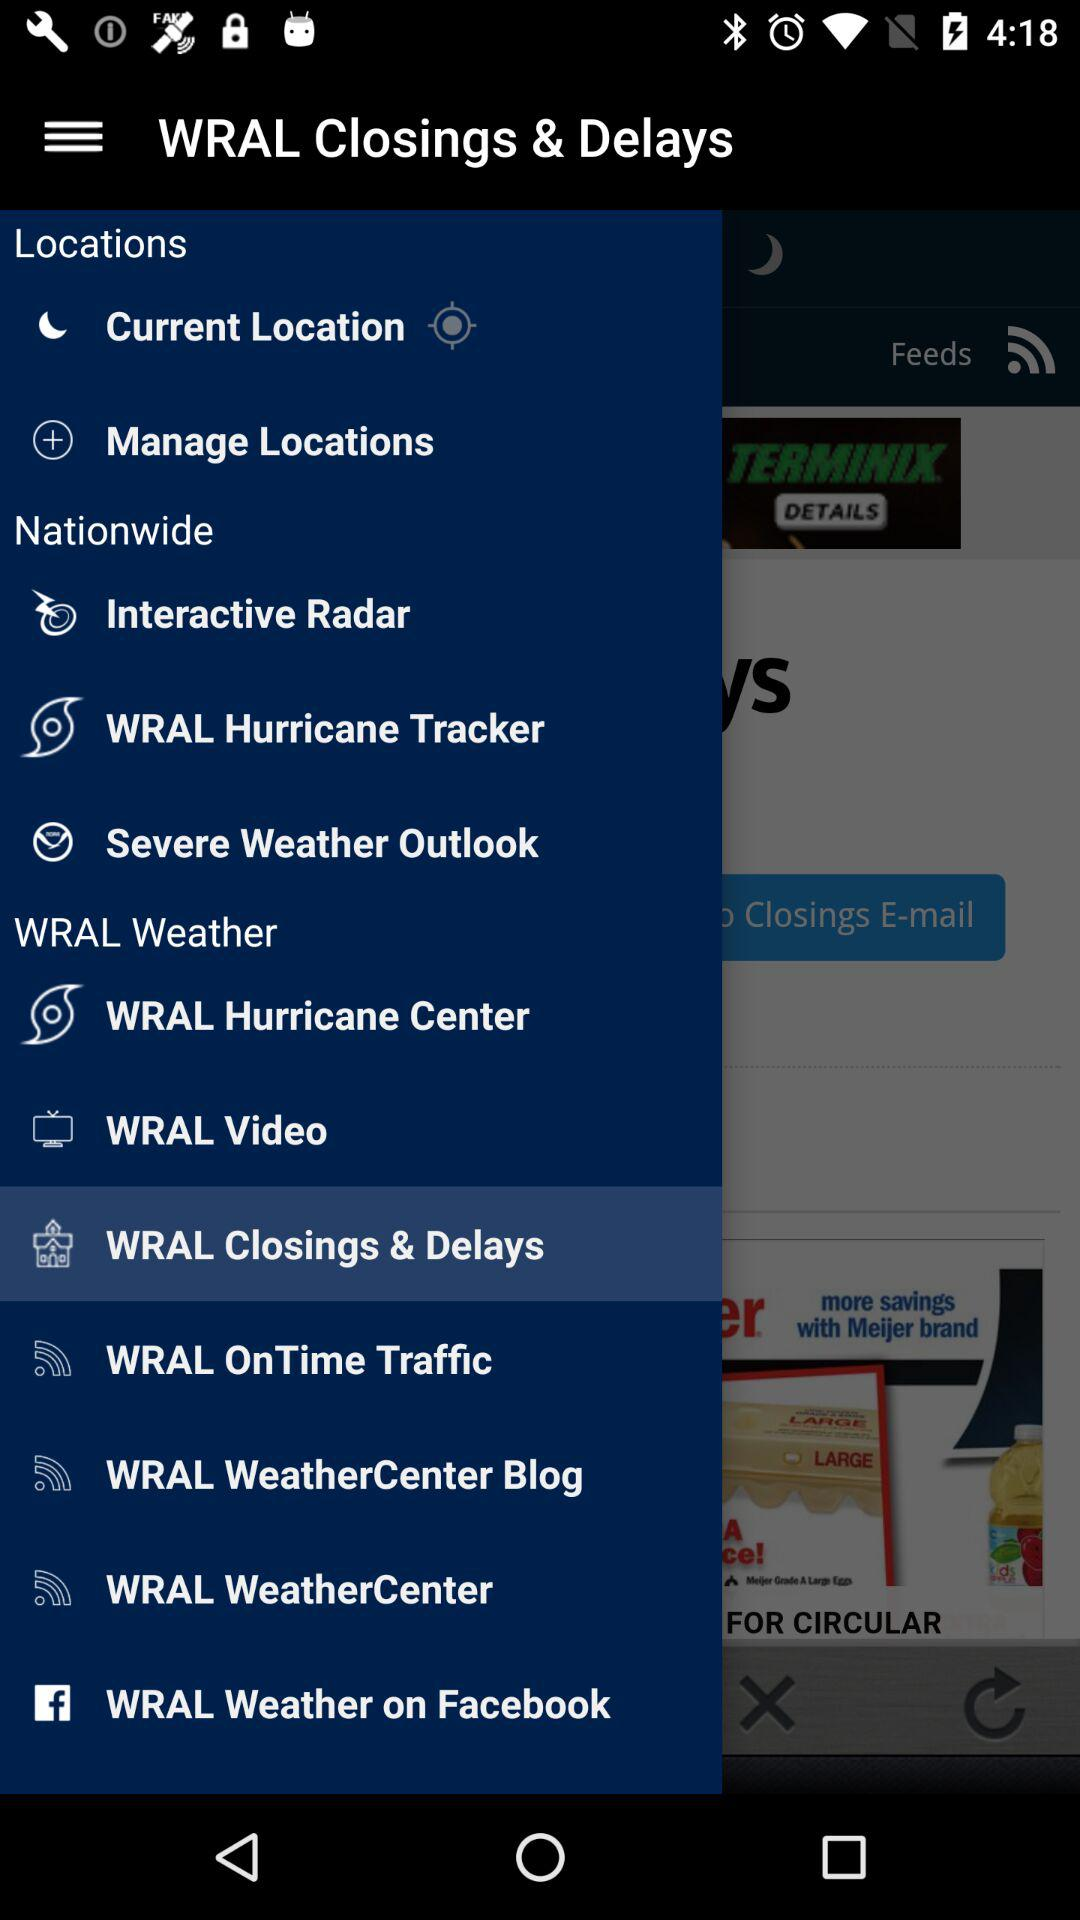What is the selected option? The selected option is "WRAL Closings & Delays". 